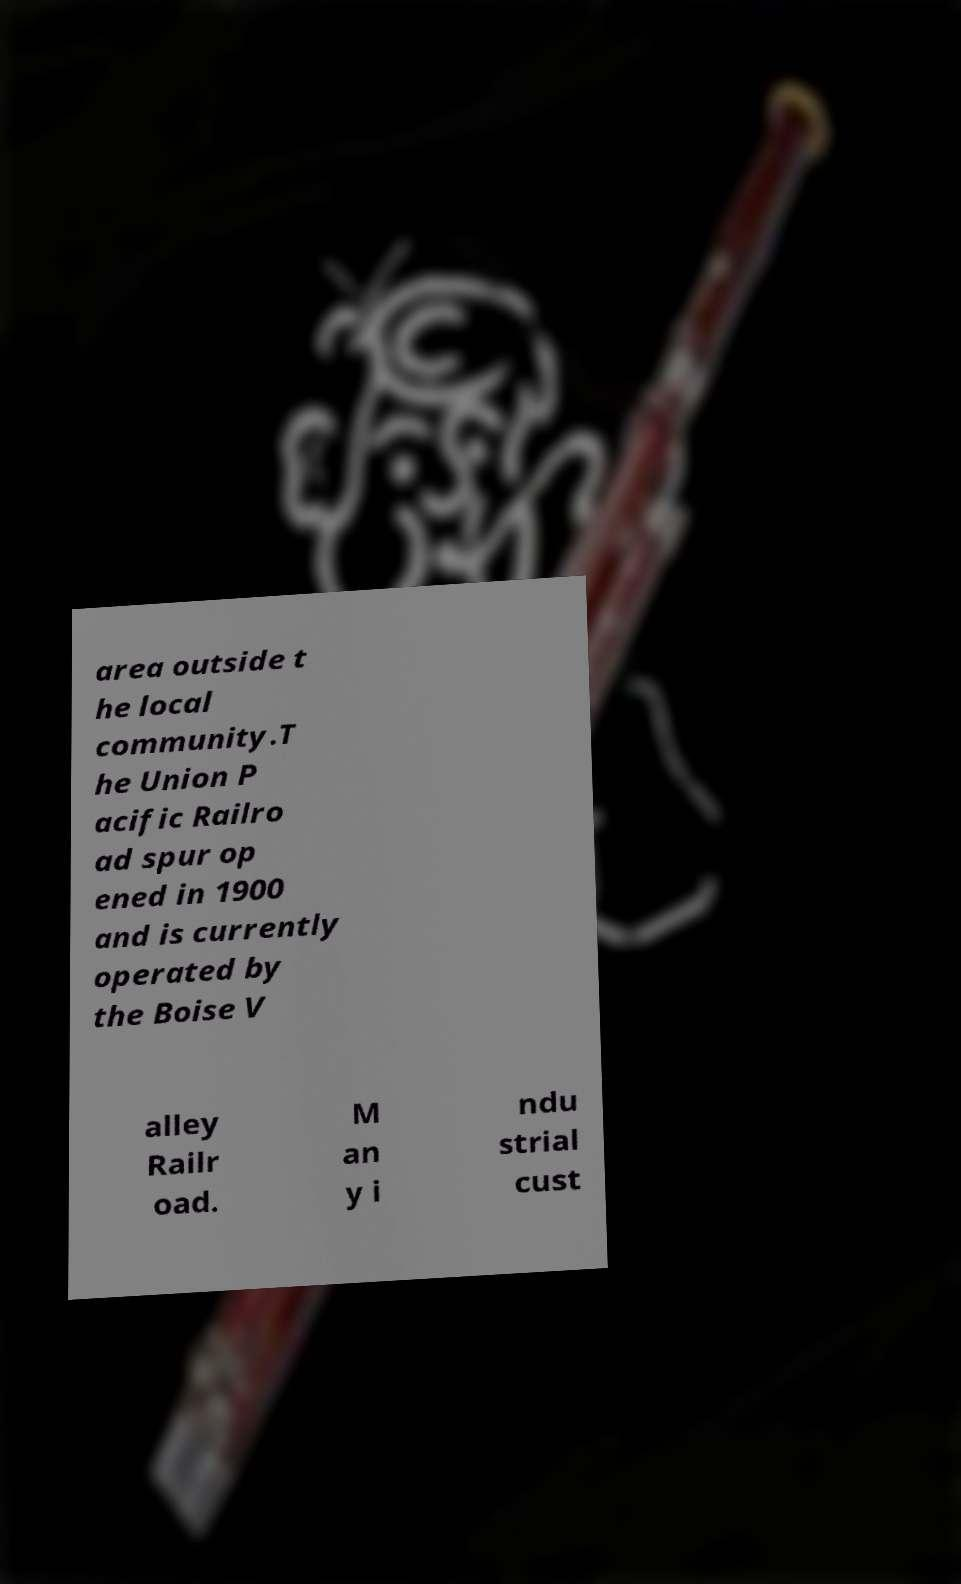Could you extract and type out the text from this image? area outside t he local community.T he Union P acific Railro ad spur op ened in 1900 and is currently operated by the Boise V alley Railr oad. M an y i ndu strial cust 